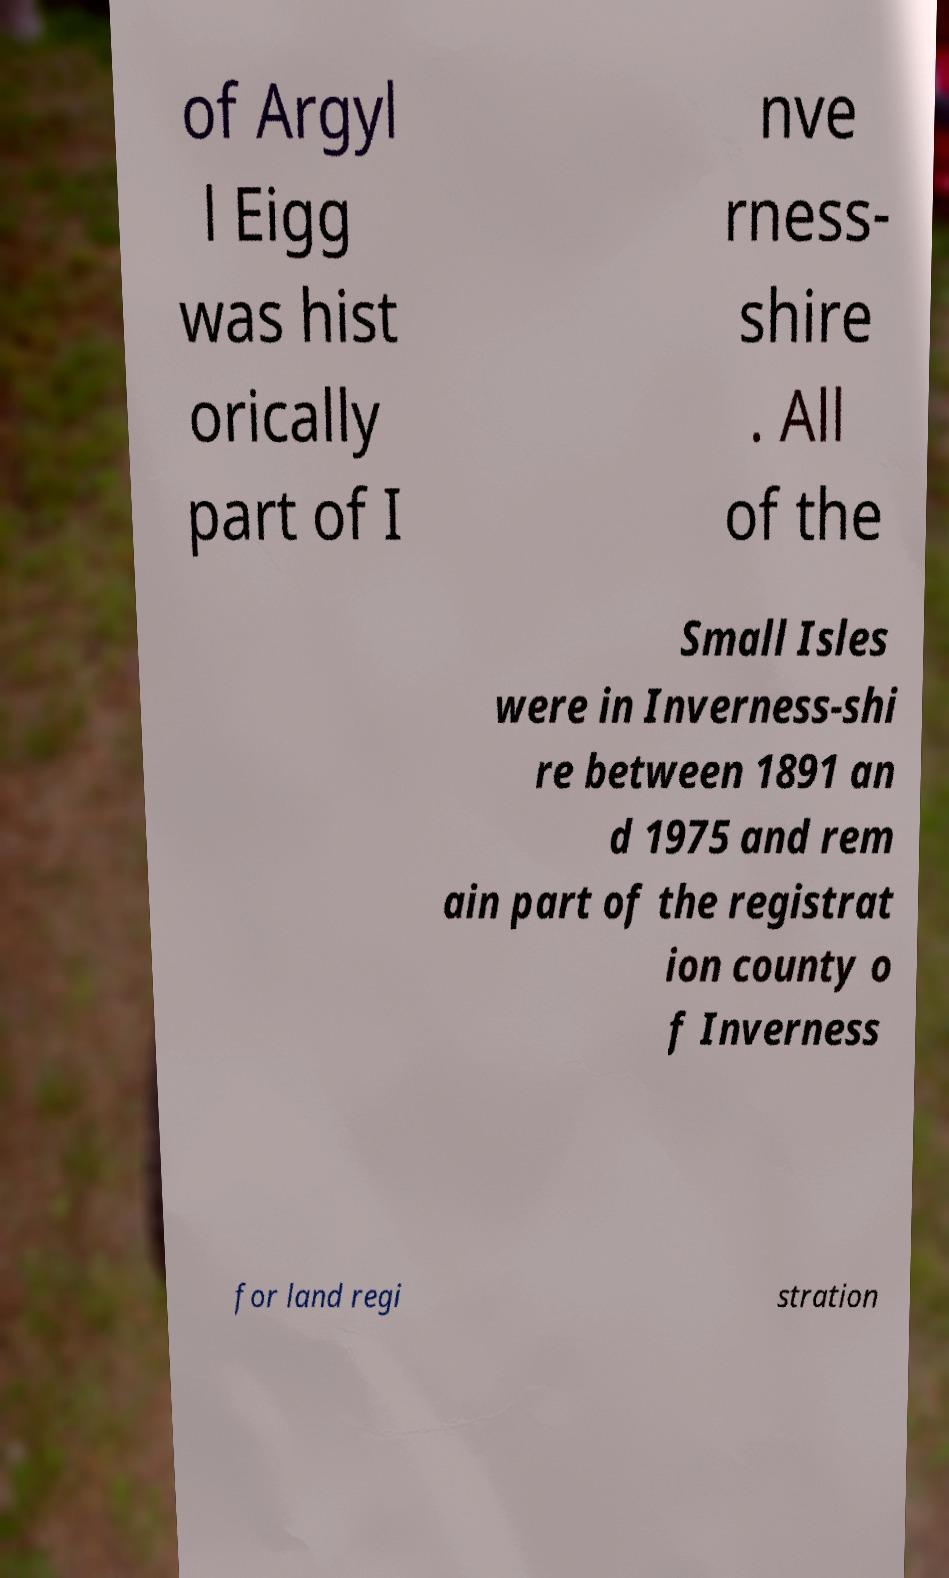Can you accurately transcribe the text from the provided image for me? of Argyl l Eigg was hist orically part of I nve rness- shire . All of the Small Isles were in Inverness-shi re between 1891 an d 1975 and rem ain part of the registrat ion county o f Inverness for land regi stration 